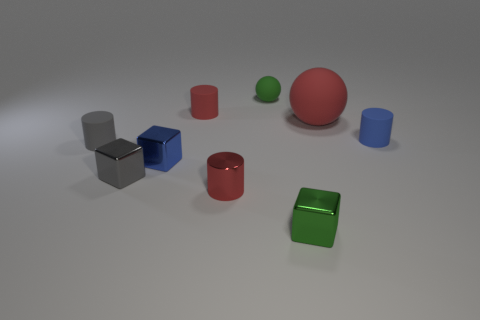Subtract all big blue spheres. Subtract all small green metal cubes. How many objects are left? 8 Add 7 green things. How many green things are left? 9 Add 8 big green rubber balls. How many big green rubber balls exist? 8 Subtract 0 brown cubes. How many objects are left? 9 Subtract all blocks. How many objects are left? 6 Subtract all cyan cylinders. Subtract all blue spheres. How many cylinders are left? 4 